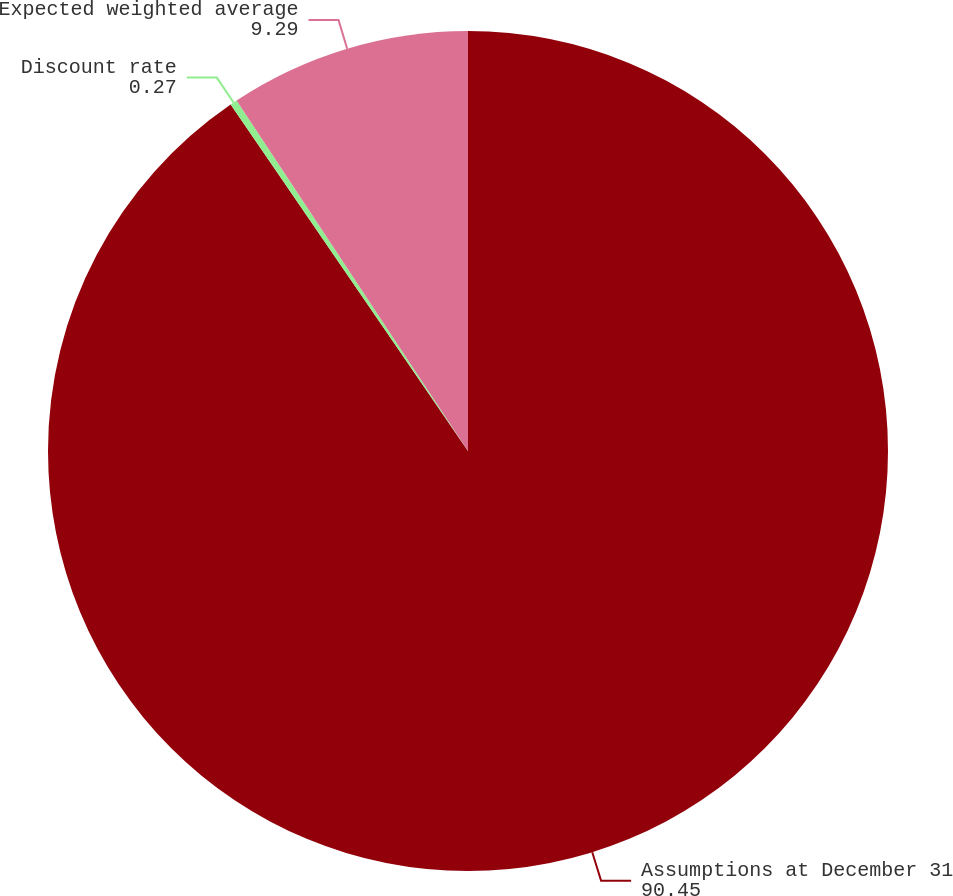Convert chart to OTSL. <chart><loc_0><loc_0><loc_500><loc_500><pie_chart><fcel>Assumptions at December 31<fcel>Discount rate<fcel>Expected weighted average<nl><fcel>90.45%<fcel>0.27%<fcel>9.29%<nl></chart> 